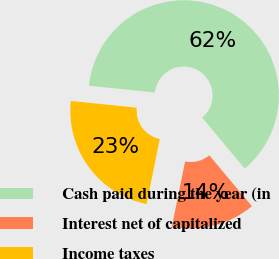Convert chart. <chart><loc_0><loc_0><loc_500><loc_500><pie_chart><fcel>Cash paid during the year (in<fcel>Interest net of capitalized<fcel>Income taxes<nl><fcel>62.3%<fcel>14.26%<fcel>23.45%<nl></chart> 